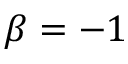Convert formula to latex. <formula><loc_0><loc_0><loc_500><loc_500>\beta = - 1</formula> 